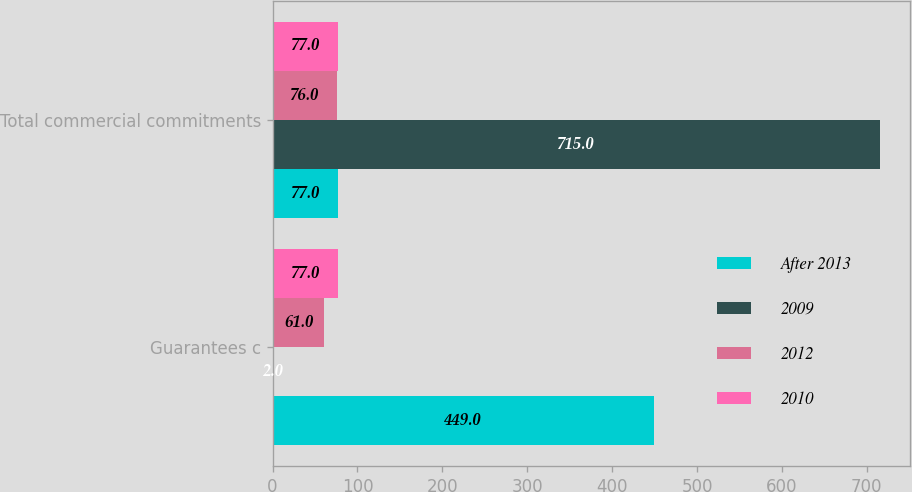<chart> <loc_0><loc_0><loc_500><loc_500><stacked_bar_chart><ecel><fcel>Guarantees c<fcel>Total commercial commitments<nl><fcel>After 2013<fcel>449<fcel>77<nl><fcel>2009<fcel>2<fcel>715<nl><fcel>2012<fcel>61<fcel>76<nl><fcel>2010<fcel>77<fcel>77<nl></chart> 